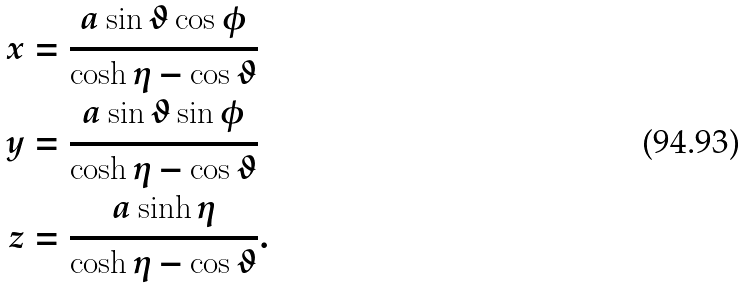Convert formula to latex. <formula><loc_0><loc_0><loc_500><loc_500>x & = \frac { a \sin \vartheta \cos \phi } { \cosh \eta - \cos \vartheta } \\ y & = \frac { a \sin \vartheta \sin \phi } { \cosh \eta - \cos \vartheta } \\ z & = \frac { a \sinh \eta } { \cosh \eta - \cos \vartheta } .</formula> 